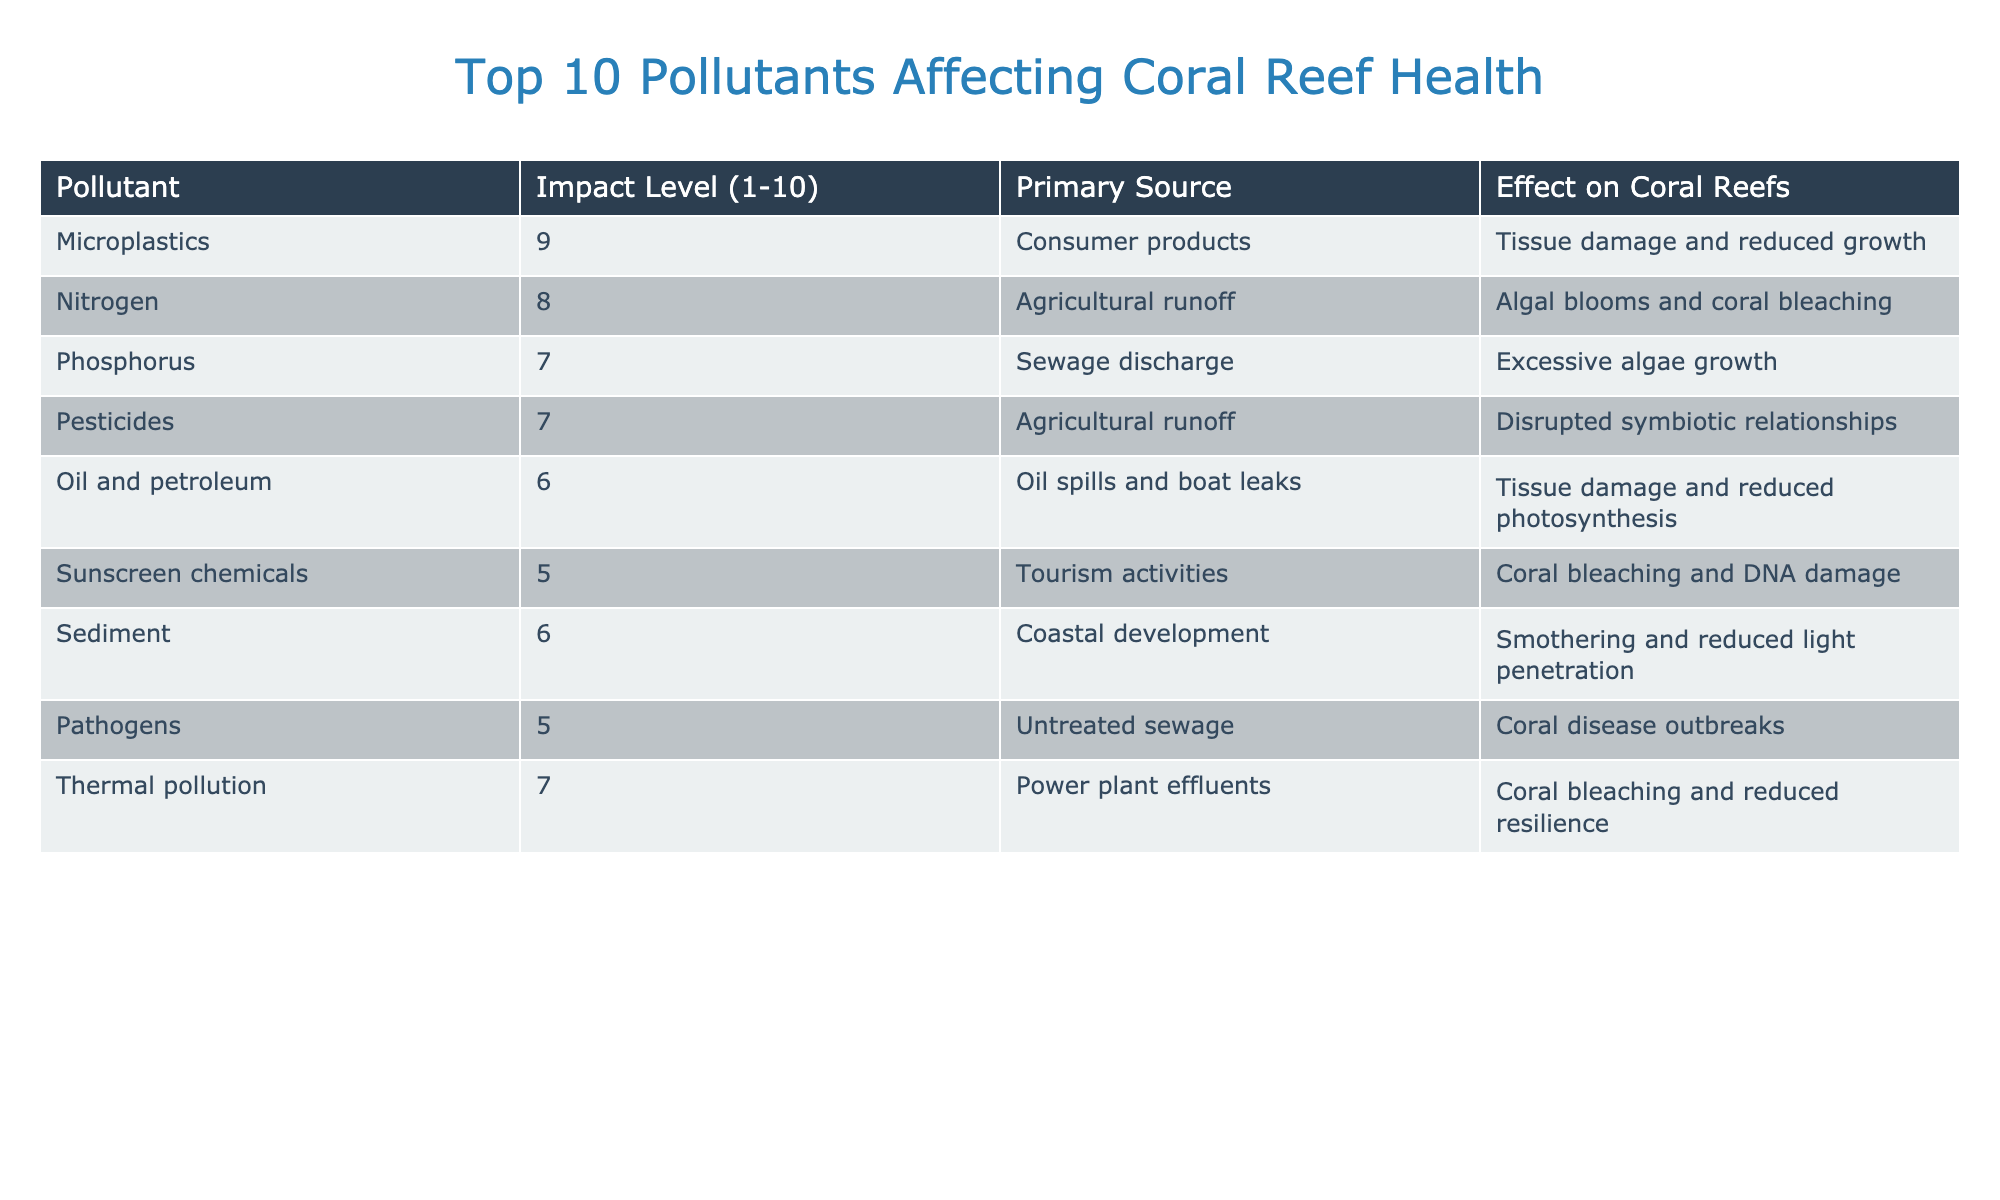What is the pollutant with the highest impact level? The table lists the impact levels of pollutants from 1 to 10. The pollutant with the highest impact level is Microplastics, which has an impact level of 9.
Answer: Microplastics Which pollutant primarily comes from agricultural runoff? The table lists two pollutants that come from agricultural runoff: Nitrogen and Pesticides. However, Nitrogen has the higher impact level (8) compared to Pesticides (7).
Answer: Nitrogen What is the average impact level of all pollutants listed? To find the average, sum up all the impact levels: 9 + 8 + 7 + 7 + 6 + 5 + 6 + 5 + 7 = 60. There are 9 pollutants, so divide 60 by 9, which equals approximately 6.67.
Answer: 6.67 Is Oil and petroleum the only pollutant affecting photosynthesis? The table indicates that Oil and petroleum affects photosynthesis, but it does not mention other pollutants affecting this process, so we assume it could be the only one listed for that effect based on available information.
Answer: Yes Find the total number of pollutants that score 7 or higher on the impact scale. Count the pollutants with an impact level of 7 or higher: Microplastics (9), Nitrogen (8), Phosphorus (7), Thermal pollution (7), and Pesticides (7). This gives a total of 5 pollutants.
Answer: 5 Which primary source has only one pollutant listed, and what is that pollutant? The table shows that Thermal pollution, with only one pollutant listed (Thermal pollution), primarily comes from power plant effluents.
Answer: Thermal pollution Do more pollutants result from agricultural runoff or tourism activities? Agricultural runoff has two pollutants (Nitrogen and Pesticides), while tourism activities have one (Sunscreen chemicals). Therefore, more pollutants come from agricultural runoff.
Answer: Agricultural runoff What is the effect of Phosphorus on coral reefs? The table states that Phosphorus leads to excessive algae growth, which can further affect coral reef health.
Answer: Excessive algae growth Which two pollutants affect coral bleaching? From the table, Nitrogen and Sunscreen chemicals are both listed under effects that lead to coral bleaching.
Answer: Nitrogen and Sunscreen chemicals Can you identify which pollutant has both tissue damage and reduced growth as an effect? The table specifically notes that Microplastics cause tissue damage and reduced growth in coral reefs.
Answer: Microplastics 